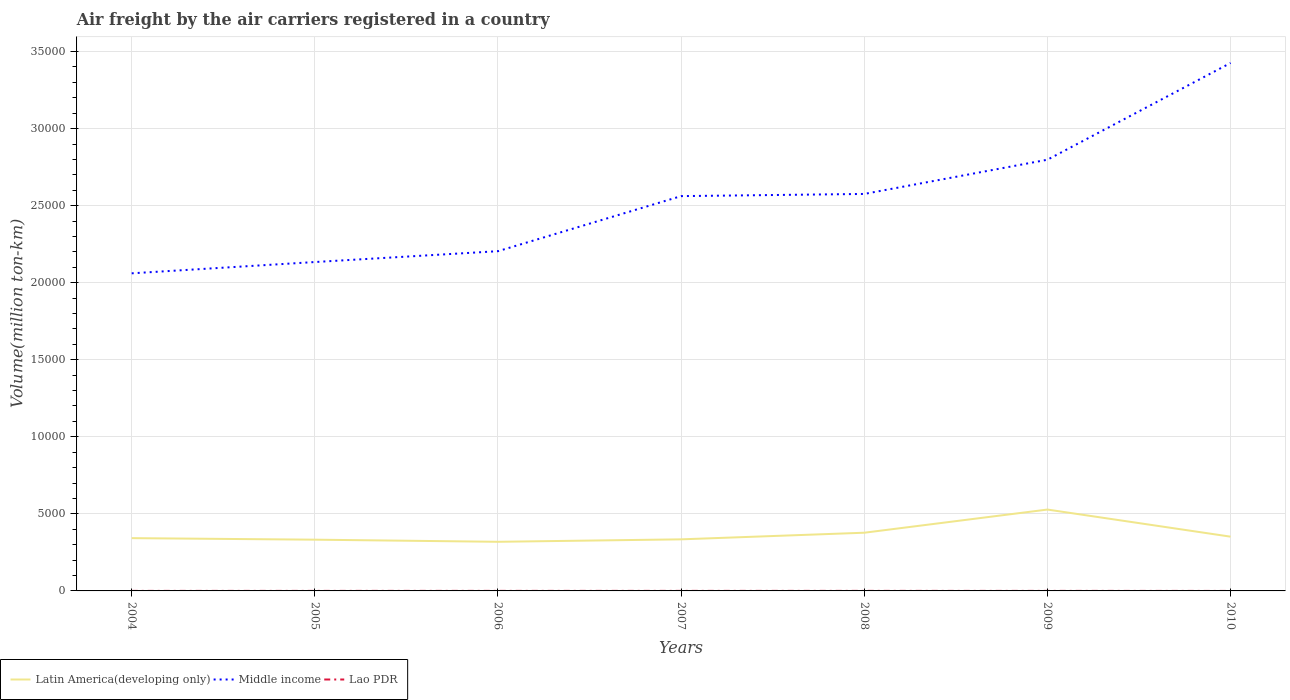How many different coloured lines are there?
Keep it short and to the point. 3. Does the line corresponding to Middle income intersect with the line corresponding to Lao PDR?
Your answer should be compact. No. Across all years, what is the maximum volume of the air carriers in Latin America(developing only)?
Offer a very short reply. 3187.2. In which year was the volume of the air carriers in Lao PDR maximum?
Your answer should be compact. 2010. What is the total volume of the air carriers in Lao PDR in the graph?
Your answer should be compact. 0.18. What is the difference between the highest and the second highest volume of the air carriers in Lao PDR?
Make the answer very short. 2.5. How many lines are there?
Ensure brevity in your answer.  3. How many years are there in the graph?
Your answer should be very brief. 7. Does the graph contain any zero values?
Ensure brevity in your answer.  No. What is the title of the graph?
Make the answer very short. Air freight by the air carriers registered in a country. Does "French Polynesia" appear as one of the legend labels in the graph?
Provide a succinct answer. No. What is the label or title of the Y-axis?
Provide a short and direct response. Volume(million ton-km). What is the Volume(million ton-km) in Latin America(developing only) in 2004?
Your response must be concise. 3425.03. What is the Volume(million ton-km) in Middle income in 2004?
Keep it short and to the point. 2.06e+04. What is the Volume(million ton-km) in Lao PDR in 2004?
Provide a short and direct response. 2.26. What is the Volume(million ton-km) of Latin America(developing only) in 2005?
Provide a short and direct response. 3325.18. What is the Volume(million ton-km) in Middle income in 2005?
Keep it short and to the point. 2.13e+04. What is the Volume(million ton-km) of Lao PDR in 2005?
Offer a terse response. 2.48. What is the Volume(million ton-km) of Latin America(developing only) in 2006?
Ensure brevity in your answer.  3187.2. What is the Volume(million ton-km) in Middle income in 2006?
Provide a short and direct response. 2.20e+04. What is the Volume(million ton-km) of Lao PDR in 2006?
Your answer should be very brief. 2.54. What is the Volume(million ton-km) of Latin America(developing only) in 2007?
Provide a succinct answer. 3347.02. What is the Volume(million ton-km) of Middle income in 2007?
Ensure brevity in your answer.  2.56e+04. What is the Volume(million ton-km) of Lao PDR in 2007?
Your answer should be compact. 2.62. What is the Volume(million ton-km) in Latin America(developing only) in 2008?
Provide a succinct answer. 3776.21. What is the Volume(million ton-km) in Middle income in 2008?
Provide a succinct answer. 2.58e+04. What is the Volume(million ton-km) of Lao PDR in 2008?
Ensure brevity in your answer.  2.58. What is the Volume(million ton-km) of Latin America(developing only) in 2009?
Ensure brevity in your answer.  5279.97. What is the Volume(million ton-km) of Middle income in 2009?
Provide a succinct answer. 2.80e+04. What is the Volume(million ton-km) of Lao PDR in 2009?
Make the answer very short. 2.37. What is the Volume(million ton-km) of Latin America(developing only) in 2010?
Provide a short and direct response. 3520.63. What is the Volume(million ton-km) of Middle income in 2010?
Keep it short and to the point. 3.43e+04. What is the Volume(million ton-km) in Lao PDR in 2010?
Provide a succinct answer. 0.12. Across all years, what is the maximum Volume(million ton-km) in Latin America(developing only)?
Make the answer very short. 5279.97. Across all years, what is the maximum Volume(million ton-km) in Middle income?
Ensure brevity in your answer.  3.43e+04. Across all years, what is the maximum Volume(million ton-km) of Lao PDR?
Offer a terse response. 2.62. Across all years, what is the minimum Volume(million ton-km) in Latin America(developing only)?
Offer a very short reply. 3187.2. Across all years, what is the minimum Volume(million ton-km) in Middle income?
Keep it short and to the point. 2.06e+04. Across all years, what is the minimum Volume(million ton-km) in Lao PDR?
Your answer should be very brief. 0.12. What is the total Volume(million ton-km) in Latin America(developing only) in the graph?
Ensure brevity in your answer.  2.59e+04. What is the total Volume(million ton-km) in Middle income in the graph?
Keep it short and to the point. 1.78e+05. What is the total Volume(million ton-km) of Lao PDR in the graph?
Make the answer very short. 14.98. What is the difference between the Volume(million ton-km) of Latin America(developing only) in 2004 and that in 2005?
Provide a short and direct response. 99.85. What is the difference between the Volume(million ton-km) of Middle income in 2004 and that in 2005?
Provide a succinct answer. -732.44. What is the difference between the Volume(million ton-km) of Lao PDR in 2004 and that in 2005?
Your answer should be very brief. -0.22. What is the difference between the Volume(million ton-km) of Latin America(developing only) in 2004 and that in 2006?
Keep it short and to the point. 237.83. What is the difference between the Volume(million ton-km) of Middle income in 2004 and that in 2006?
Offer a very short reply. -1436.24. What is the difference between the Volume(million ton-km) in Lao PDR in 2004 and that in 2006?
Keep it short and to the point. -0.28. What is the difference between the Volume(million ton-km) in Latin America(developing only) in 2004 and that in 2007?
Make the answer very short. 78.01. What is the difference between the Volume(million ton-km) in Middle income in 2004 and that in 2007?
Provide a succinct answer. -5009.58. What is the difference between the Volume(million ton-km) in Lao PDR in 2004 and that in 2007?
Your answer should be compact. -0.36. What is the difference between the Volume(million ton-km) in Latin America(developing only) in 2004 and that in 2008?
Give a very brief answer. -351.19. What is the difference between the Volume(million ton-km) in Middle income in 2004 and that in 2008?
Provide a succinct answer. -5150.93. What is the difference between the Volume(million ton-km) of Lao PDR in 2004 and that in 2008?
Make the answer very short. -0.32. What is the difference between the Volume(million ton-km) of Latin America(developing only) in 2004 and that in 2009?
Your response must be concise. -1854.94. What is the difference between the Volume(million ton-km) of Middle income in 2004 and that in 2009?
Offer a terse response. -7371.09. What is the difference between the Volume(million ton-km) in Lao PDR in 2004 and that in 2009?
Your answer should be compact. -0.11. What is the difference between the Volume(million ton-km) of Latin America(developing only) in 2004 and that in 2010?
Offer a terse response. -95.61. What is the difference between the Volume(million ton-km) in Middle income in 2004 and that in 2010?
Give a very brief answer. -1.36e+04. What is the difference between the Volume(million ton-km) in Lao PDR in 2004 and that in 2010?
Provide a short and direct response. 2.14. What is the difference between the Volume(million ton-km) in Latin America(developing only) in 2005 and that in 2006?
Your answer should be compact. 137.98. What is the difference between the Volume(million ton-km) in Middle income in 2005 and that in 2006?
Your answer should be very brief. -703.79. What is the difference between the Volume(million ton-km) in Lao PDR in 2005 and that in 2006?
Your response must be concise. -0.06. What is the difference between the Volume(million ton-km) in Latin America(developing only) in 2005 and that in 2007?
Your answer should be compact. -21.84. What is the difference between the Volume(million ton-km) in Middle income in 2005 and that in 2007?
Ensure brevity in your answer.  -4277.14. What is the difference between the Volume(million ton-km) in Lao PDR in 2005 and that in 2007?
Your answer should be compact. -0.14. What is the difference between the Volume(million ton-km) of Latin America(developing only) in 2005 and that in 2008?
Your answer should be compact. -451.04. What is the difference between the Volume(million ton-km) of Middle income in 2005 and that in 2008?
Ensure brevity in your answer.  -4418.49. What is the difference between the Volume(million ton-km) in Lao PDR in 2005 and that in 2008?
Your response must be concise. -0.1. What is the difference between the Volume(million ton-km) of Latin America(developing only) in 2005 and that in 2009?
Your answer should be very brief. -1954.8. What is the difference between the Volume(million ton-km) of Middle income in 2005 and that in 2009?
Offer a very short reply. -6638.65. What is the difference between the Volume(million ton-km) of Lao PDR in 2005 and that in 2009?
Provide a succinct answer. 0.11. What is the difference between the Volume(million ton-km) of Latin America(developing only) in 2005 and that in 2010?
Keep it short and to the point. -195.46. What is the difference between the Volume(million ton-km) of Middle income in 2005 and that in 2010?
Provide a short and direct response. -1.29e+04. What is the difference between the Volume(million ton-km) in Lao PDR in 2005 and that in 2010?
Provide a short and direct response. 2.36. What is the difference between the Volume(million ton-km) in Latin America(developing only) in 2006 and that in 2007?
Offer a very short reply. -159.82. What is the difference between the Volume(million ton-km) in Middle income in 2006 and that in 2007?
Ensure brevity in your answer.  -3573.34. What is the difference between the Volume(million ton-km) of Lao PDR in 2006 and that in 2007?
Provide a short and direct response. -0.08. What is the difference between the Volume(million ton-km) in Latin America(developing only) in 2006 and that in 2008?
Offer a terse response. -589.02. What is the difference between the Volume(million ton-km) of Middle income in 2006 and that in 2008?
Provide a succinct answer. -3714.7. What is the difference between the Volume(million ton-km) of Lao PDR in 2006 and that in 2008?
Your answer should be compact. -0.03. What is the difference between the Volume(million ton-km) in Latin America(developing only) in 2006 and that in 2009?
Your answer should be compact. -2092.77. What is the difference between the Volume(million ton-km) of Middle income in 2006 and that in 2009?
Ensure brevity in your answer.  -5934.85. What is the difference between the Volume(million ton-km) of Lao PDR in 2006 and that in 2009?
Your answer should be compact. 0.18. What is the difference between the Volume(million ton-km) in Latin America(developing only) in 2006 and that in 2010?
Your response must be concise. -333.44. What is the difference between the Volume(million ton-km) in Middle income in 2006 and that in 2010?
Make the answer very short. -1.22e+04. What is the difference between the Volume(million ton-km) in Lao PDR in 2006 and that in 2010?
Ensure brevity in your answer.  2.42. What is the difference between the Volume(million ton-km) of Latin America(developing only) in 2007 and that in 2008?
Offer a very short reply. -429.2. What is the difference between the Volume(million ton-km) in Middle income in 2007 and that in 2008?
Your answer should be compact. -141.35. What is the difference between the Volume(million ton-km) of Lao PDR in 2007 and that in 2008?
Give a very brief answer. 0.05. What is the difference between the Volume(million ton-km) in Latin America(developing only) in 2007 and that in 2009?
Your answer should be compact. -1932.95. What is the difference between the Volume(million ton-km) of Middle income in 2007 and that in 2009?
Your answer should be very brief. -2361.51. What is the difference between the Volume(million ton-km) of Lao PDR in 2007 and that in 2009?
Your answer should be very brief. 0.26. What is the difference between the Volume(million ton-km) in Latin America(developing only) in 2007 and that in 2010?
Your answer should be very brief. -173.62. What is the difference between the Volume(million ton-km) in Middle income in 2007 and that in 2010?
Offer a very short reply. -8639.5. What is the difference between the Volume(million ton-km) in Lao PDR in 2007 and that in 2010?
Offer a very short reply. 2.5. What is the difference between the Volume(million ton-km) in Latin America(developing only) in 2008 and that in 2009?
Your response must be concise. -1503.76. What is the difference between the Volume(million ton-km) of Middle income in 2008 and that in 2009?
Provide a succinct answer. -2220.16. What is the difference between the Volume(million ton-km) in Lao PDR in 2008 and that in 2009?
Your answer should be compact. 0.21. What is the difference between the Volume(million ton-km) of Latin America(developing only) in 2008 and that in 2010?
Offer a terse response. 255.58. What is the difference between the Volume(million ton-km) of Middle income in 2008 and that in 2010?
Provide a short and direct response. -8498.15. What is the difference between the Volume(million ton-km) in Lao PDR in 2008 and that in 2010?
Give a very brief answer. 2.46. What is the difference between the Volume(million ton-km) in Latin America(developing only) in 2009 and that in 2010?
Provide a short and direct response. 1759.34. What is the difference between the Volume(million ton-km) in Middle income in 2009 and that in 2010?
Your answer should be very brief. -6278. What is the difference between the Volume(million ton-km) of Lao PDR in 2009 and that in 2010?
Give a very brief answer. 2.25. What is the difference between the Volume(million ton-km) in Latin America(developing only) in 2004 and the Volume(million ton-km) in Middle income in 2005?
Make the answer very short. -1.79e+04. What is the difference between the Volume(million ton-km) in Latin America(developing only) in 2004 and the Volume(million ton-km) in Lao PDR in 2005?
Offer a terse response. 3422.55. What is the difference between the Volume(million ton-km) of Middle income in 2004 and the Volume(million ton-km) of Lao PDR in 2005?
Keep it short and to the point. 2.06e+04. What is the difference between the Volume(million ton-km) in Latin America(developing only) in 2004 and the Volume(million ton-km) in Middle income in 2006?
Give a very brief answer. -1.86e+04. What is the difference between the Volume(million ton-km) of Latin America(developing only) in 2004 and the Volume(million ton-km) of Lao PDR in 2006?
Make the answer very short. 3422.48. What is the difference between the Volume(million ton-km) in Middle income in 2004 and the Volume(million ton-km) in Lao PDR in 2006?
Your answer should be compact. 2.06e+04. What is the difference between the Volume(million ton-km) of Latin America(developing only) in 2004 and the Volume(million ton-km) of Middle income in 2007?
Your answer should be very brief. -2.22e+04. What is the difference between the Volume(million ton-km) of Latin America(developing only) in 2004 and the Volume(million ton-km) of Lao PDR in 2007?
Offer a very short reply. 3422.4. What is the difference between the Volume(million ton-km) in Middle income in 2004 and the Volume(million ton-km) in Lao PDR in 2007?
Provide a short and direct response. 2.06e+04. What is the difference between the Volume(million ton-km) in Latin America(developing only) in 2004 and the Volume(million ton-km) in Middle income in 2008?
Make the answer very short. -2.23e+04. What is the difference between the Volume(million ton-km) in Latin America(developing only) in 2004 and the Volume(million ton-km) in Lao PDR in 2008?
Ensure brevity in your answer.  3422.45. What is the difference between the Volume(million ton-km) in Middle income in 2004 and the Volume(million ton-km) in Lao PDR in 2008?
Your response must be concise. 2.06e+04. What is the difference between the Volume(million ton-km) of Latin America(developing only) in 2004 and the Volume(million ton-km) of Middle income in 2009?
Offer a terse response. -2.46e+04. What is the difference between the Volume(million ton-km) in Latin America(developing only) in 2004 and the Volume(million ton-km) in Lao PDR in 2009?
Your response must be concise. 3422.66. What is the difference between the Volume(million ton-km) in Middle income in 2004 and the Volume(million ton-km) in Lao PDR in 2009?
Provide a short and direct response. 2.06e+04. What is the difference between the Volume(million ton-km) of Latin America(developing only) in 2004 and the Volume(million ton-km) of Middle income in 2010?
Keep it short and to the point. -3.08e+04. What is the difference between the Volume(million ton-km) of Latin America(developing only) in 2004 and the Volume(million ton-km) of Lao PDR in 2010?
Your answer should be very brief. 3424.9. What is the difference between the Volume(million ton-km) in Middle income in 2004 and the Volume(million ton-km) in Lao PDR in 2010?
Offer a terse response. 2.06e+04. What is the difference between the Volume(million ton-km) of Latin America(developing only) in 2005 and the Volume(million ton-km) of Middle income in 2006?
Offer a terse response. -1.87e+04. What is the difference between the Volume(million ton-km) of Latin America(developing only) in 2005 and the Volume(million ton-km) of Lao PDR in 2006?
Your response must be concise. 3322.63. What is the difference between the Volume(million ton-km) in Middle income in 2005 and the Volume(million ton-km) in Lao PDR in 2006?
Provide a short and direct response. 2.13e+04. What is the difference between the Volume(million ton-km) of Latin America(developing only) in 2005 and the Volume(million ton-km) of Middle income in 2007?
Ensure brevity in your answer.  -2.23e+04. What is the difference between the Volume(million ton-km) of Latin America(developing only) in 2005 and the Volume(million ton-km) of Lao PDR in 2007?
Make the answer very short. 3322.55. What is the difference between the Volume(million ton-km) in Middle income in 2005 and the Volume(million ton-km) in Lao PDR in 2007?
Your answer should be very brief. 2.13e+04. What is the difference between the Volume(million ton-km) in Latin America(developing only) in 2005 and the Volume(million ton-km) in Middle income in 2008?
Keep it short and to the point. -2.24e+04. What is the difference between the Volume(million ton-km) of Latin America(developing only) in 2005 and the Volume(million ton-km) of Lao PDR in 2008?
Make the answer very short. 3322.6. What is the difference between the Volume(million ton-km) of Middle income in 2005 and the Volume(million ton-km) of Lao PDR in 2008?
Your answer should be compact. 2.13e+04. What is the difference between the Volume(million ton-km) in Latin America(developing only) in 2005 and the Volume(million ton-km) in Middle income in 2009?
Your answer should be compact. -2.47e+04. What is the difference between the Volume(million ton-km) in Latin America(developing only) in 2005 and the Volume(million ton-km) in Lao PDR in 2009?
Keep it short and to the point. 3322.81. What is the difference between the Volume(million ton-km) in Middle income in 2005 and the Volume(million ton-km) in Lao PDR in 2009?
Make the answer very short. 2.13e+04. What is the difference between the Volume(million ton-km) of Latin America(developing only) in 2005 and the Volume(million ton-km) of Middle income in 2010?
Provide a succinct answer. -3.09e+04. What is the difference between the Volume(million ton-km) in Latin America(developing only) in 2005 and the Volume(million ton-km) in Lao PDR in 2010?
Your answer should be compact. 3325.05. What is the difference between the Volume(million ton-km) of Middle income in 2005 and the Volume(million ton-km) of Lao PDR in 2010?
Your answer should be compact. 2.13e+04. What is the difference between the Volume(million ton-km) in Latin America(developing only) in 2006 and the Volume(million ton-km) in Middle income in 2007?
Provide a succinct answer. -2.24e+04. What is the difference between the Volume(million ton-km) in Latin America(developing only) in 2006 and the Volume(million ton-km) in Lao PDR in 2007?
Your answer should be compact. 3184.57. What is the difference between the Volume(million ton-km) in Middle income in 2006 and the Volume(million ton-km) in Lao PDR in 2007?
Your answer should be very brief. 2.20e+04. What is the difference between the Volume(million ton-km) of Latin America(developing only) in 2006 and the Volume(million ton-km) of Middle income in 2008?
Give a very brief answer. -2.26e+04. What is the difference between the Volume(million ton-km) of Latin America(developing only) in 2006 and the Volume(million ton-km) of Lao PDR in 2008?
Give a very brief answer. 3184.62. What is the difference between the Volume(million ton-km) in Middle income in 2006 and the Volume(million ton-km) in Lao PDR in 2008?
Give a very brief answer. 2.20e+04. What is the difference between the Volume(million ton-km) of Latin America(developing only) in 2006 and the Volume(million ton-km) of Middle income in 2009?
Your answer should be very brief. -2.48e+04. What is the difference between the Volume(million ton-km) of Latin America(developing only) in 2006 and the Volume(million ton-km) of Lao PDR in 2009?
Your answer should be compact. 3184.83. What is the difference between the Volume(million ton-km) in Middle income in 2006 and the Volume(million ton-km) in Lao PDR in 2009?
Your answer should be compact. 2.20e+04. What is the difference between the Volume(million ton-km) of Latin America(developing only) in 2006 and the Volume(million ton-km) of Middle income in 2010?
Your response must be concise. -3.11e+04. What is the difference between the Volume(million ton-km) of Latin America(developing only) in 2006 and the Volume(million ton-km) of Lao PDR in 2010?
Ensure brevity in your answer.  3187.07. What is the difference between the Volume(million ton-km) of Middle income in 2006 and the Volume(million ton-km) of Lao PDR in 2010?
Your response must be concise. 2.20e+04. What is the difference between the Volume(million ton-km) of Latin America(developing only) in 2007 and the Volume(million ton-km) of Middle income in 2008?
Provide a succinct answer. -2.24e+04. What is the difference between the Volume(million ton-km) in Latin America(developing only) in 2007 and the Volume(million ton-km) in Lao PDR in 2008?
Give a very brief answer. 3344.44. What is the difference between the Volume(million ton-km) in Middle income in 2007 and the Volume(million ton-km) in Lao PDR in 2008?
Your answer should be very brief. 2.56e+04. What is the difference between the Volume(million ton-km) in Latin America(developing only) in 2007 and the Volume(million ton-km) in Middle income in 2009?
Your answer should be compact. -2.46e+04. What is the difference between the Volume(million ton-km) in Latin America(developing only) in 2007 and the Volume(million ton-km) in Lao PDR in 2009?
Ensure brevity in your answer.  3344.65. What is the difference between the Volume(million ton-km) in Middle income in 2007 and the Volume(million ton-km) in Lao PDR in 2009?
Make the answer very short. 2.56e+04. What is the difference between the Volume(million ton-km) of Latin America(developing only) in 2007 and the Volume(million ton-km) of Middle income in 2010?
Keep it short and to the point. -3.09e+04. What is the difference between the Volume(million ton-km) in Latin America(developing only) in 2007 and the Volume(million ton-km) in Lao PDR in 2010?
Offer a very short reply. 3346.89. What is the difference between the Volume(million ton-km) in Middle income in 2007 and the Volume(million ton-km) in Lao PDR in 2010?
Give a very brief answer. 2.56e+04. What is the difference between the Volume(million ton-km) in Latin America(developing only) in 2008 and the Volume(million ton-km) in Middle income in 2009?
Your answer should be compact. -2.42e+04. What is the difference between the Volume(million ton-km) in Latin America(developing only) in 2008 and the Volume(million ton-km) in Lao PDR in 2009?
Your answer should be very brief. 3773.85. What is the difference between the Volume(million ton-km) of Middle income in 2008 and the Volume(million ton-km) of Lao PDR in 2009?
Offer a very short reply. 2.58e+04. What is the difference between the Volume(million ton-km) of Latin America(developing only) in 2008 and the Volume(million ton-km) of Middle income in 2010?
Offer a terse response. -3.05e+04. What is the difference between the Volume(million ton-km) of Latin America(developing only) in 2008 and the Volume(million ton-km) of Lao PDR in 2010?
Make the answer very short. 3776.09. What is the difference between the Volume(million ton-km) in Middle income in 2008 and the Volume(million ton-km) in Lao PDR in 2010?
Ensure brevity in your answer.  2.58e+04. What is the difference between the Volume(million ton-km) in Latin America(developing only) in 2009 and the Volume(million ton-km) in Middle income in 2010?
Your answer should be very brief. -2.90e+04. What is the difference between the Volume(million ton-km) in Latin America(developing only) in 2009 and the Volume(million ton-km) in Lao PDR in 2010?
Your response must be concise. 5279.85. What is the difference between the Volume(million ton-km) of Middle income in 2009 and the Volume(million ton-km) of Lao PDR in 2010?
Provide a succinct answer. 2.80e+04. What is the average Volume(million ton-km) in Latin America(developing only) per year?
Ensure brevity in your answer.  3694.46. What is the average Volume(million ton-km) in Middle income per year?
Keep it short and to the point. 2.54e+04. What is the average Volume(million ton-km) of Lao PDR per year?
Ensure brevity in your answer.  2.14. In the year 2004, what is the difference between the Volume(million ton-km) in Latin America(developing only) and Volume(million ton-km) in Middle income?
Your answer should be compact. -1.72e+04. In the year 2004, what is the difference between the Volume(million ton-km) in Latin America(developing only) and Volume(million ton-km) in Lao PDR?
Provide a short and direct response. 3422.76. In the year 2004, what is the difference between the Volume(million ton-km) of Middle income and Volume(million ton-km) of Lao PDR?
Give a very brief answer. 2.06e+04. In the year 2005, what is the difference between the Volume(million ton-km) of Latin America(developing only) and Volume(million ton-km) of Middle income?
Make the answer very short. -1.80e+04. In the year 2005, what is the difference between the Volume(million ton-km) of Latin America(developing only) and Volume(million ton-km) of Lao PDR?
Give a very brief answer. 3322.7. In the year 2005, what is the difference between the Volume(million ton-km) in Middle income and Volume(million ton-km) in Lao PDR?
Your answer should be very brief. 2.13e+04. In the year 2006, what is the difference between the Volume(million ton-km) of Latin America(developing only) and Volume(million ton-km) of Middle income?
Ensure brevity in your answer.  -1.89e+04. In the year 2006, what is the difference between the Volume(million ton-km) in Latin America(developing only) and Volume(million ton-km) in Lao PDR?
Provide a succinct answer. 3184.65. In the year 2006, what is the difference between the Volume(million ton-km) in Middle income and Volume(million ton-km) in Lao PDR?
Ensure brevity in your answer.  2.20e+04. In the year 2007, what is the difference between the Volume(million ton-km) of Latin America(developing only) and Volume(million ton-km) of Middle income?
Ensure brevity in your answer.  -2.23e+04. In the year 2007, what is the difference between the Volume(million ton-km) in Latin America(developing only) and Volume(million ton-km) in Lao PDR?
Offer a terse response. 3344.39. In the year 2007, what is the difference between the Volume(million ton-km) of Middle income and Volume(million ton-km) of Lao PDR?
Offer a terse response. 2.56e+04. In the year 2008, what is the difference between the Volume(million ton-km) of Latin America(developing only) and Volume(million ton-km) of Middle income?
Your response must be concise. -2.20e+04. In the year 2008, what is the difference between the Volume(million ton-km) in Latin America(developing only) and Volume(million ton-km) in Lao PDR?
Offer a terse response. 3773.64. In the year 2008, what is the difference between the Volume(million ton-km) in Middle income and Volume(million ton-km) in Lao PDR?
Give a very brief answer. 2.58e+04. In the year 2009, what is the difference between the Volume(million ton-km) of Latin America(developing only) and Volume(million ton-km) of Middle income?
Make the answer very short. -2.27e+04. In the year 2009, what is the difference between the Volume(million ton-km) in Latin America(developing only) and Volume(million ton-km) in Lao PDR?
Your answer should be compact. 5277.6. In the year 2009, what is the difference between the Volume(million ton-km) of Middle income and Volume(million ton-km) of Lao PDR?
Offer a very short reply. 2.80e+04. In the year 2010, what is the difference between the Volume(million ton-km) of Latin America(developing only) and Volume(million ton-km) of Middle income?
Your answer should be very brief. -3.07e+04. In the year 2010, what is the difference between the Volume(million ton-km) in Latin America(developing only) and Volume(million ton-km) in Lao PDR?
Offer a very short reply. 3520.51. In the year 2010, what is the difference between the Volume(million ton-km) of Middle income and Volume(million ton-km) of Lao PDR?
Provide a short and direct response. 3.43e+04. What is the ratio of the Volume(million ton-km) in Middle income in 2004 to that in 2005?
Offer a terse response. 0.97. What is the ratio of the Volume(million ton-km) of Lao PDR in 2004 to that in 2005?
Provide a succinct answer. 0.91. What is the ratio of the Volume(million ton-km) in Latin America(developing only) in 2004 to that in 2006?
Your response must be concise. 1.07. What is the ratio of the Volume(million ton-km) in Middle income in 2004 to that in 2006?
Your answer should be compact. 0.93. What is the ratio of the Volume(million ton-km) of Lao PDR in 2004 to that in 2006?
Your response must be concise. 0.89. What is the ratio of the Volume(million ton-km) in Latin America(developing only) in 2004 to that in 2007?
Keep it short and to the point. 1.02. What is the ratio of the Volume(million ton-km) in Middle income in 2004 to that in 2007?
Provide a succinct answer. 0.8. What is the ratio of the Volume(million ton-km) of Lao PDR in 2004 to that in 2007?
Provide a short and direct response. 0.86. What is the ratio of the Volume(million ton-km) in Latin America(developing only) in 2004 to that in 2008?
Give a very brief answer. 0.91. What is the ratio of the Volume(million ton-km) in Middle income in 2004 to that in 2008?
Offer a terse response. 0.8. What is the ratio of the Volume(million ton-km) in Lao PDR in 2004 to that in 2008?
Provide a succinct answer. 0.88. What is the ratio of the Volume(million ton-km) in Latin America(developing only) in 2004 to that in 2009?
Keep it short and to the point. 0.65. What is the ratio of the Volume(million ton-km) of Middle income in 2004 to that in 2009?
Your response must be concise. 0.74. What is the ratio of the Volume(million ton-km) of Lao PDR in 2004 to that in 2009?
Provide a short and direct response. 0.96. What is the ratio of the Volume(million ton-km) of Latin America(developing only) in 2004 to that in 2010?
Give a very brief answer. 0.97. What is the ratio of the Volume(million ton-km) in Middle income in 2004 to that in 2010?
Your answer should be very brief. 0.6. What is the ratio of the Volume(million ton-km) in Lao PDR in 2004 to that in 2010?
Make the answer very short. 18.53. What is the ratio of the Volume(million ton-km) in Latin America(developing only) in 2005 to that in 2006?
Give a very brief answer. 1.04. What is the ratio of the Volume(million ton-km) in Middle income in 2005 to that in 2006?
Provide a succinct answer. 0.97. What is the ratio of the Volume(million ton-km) of Lao PDR in 2005 to that in 2006?
Provide a short and direct response. 0.97. What is the ratio of the Volume(million ton-km) of Latin America(developing only) in 2005 to that in 2007?
Your answer should be compact. 0.99. What is the ratio of the Volume(million ton-km) of Middle income in 2005 to that in 2007?
Offer a very short reply. 0.83. What is the ratio of the Volume(million ton-km) in Lao PDR in 2005 to that in 2007?
Give a very brief answer. 0.95. What is the ratio of the Volume(million ton-km) of Latin America(developing only) in 2005 to that in 2008?
Your answer should be compact. 0.88. What is the ratio of the Volume(million ton-km) of Middle income in 2005 to that in 2008?
Provide a succinct answer. 0.83. What is the ratio of the Volume(million ton-km) in Latin America(developing only) in 2005 to that in 2009?
Make the answer very short. 0.63. What is the ratio of the Volume(million ton-km) of Middle income in 2005 to that in 2009?
Your response must be concise. 0.76. What is the ratio of the Volume(million ton-km) of Lao PDR in 2005 to that in 2009?
Provide a succinct answer. 1.05. What is the ratio of the Volume(million ton-km) of Latin America(developing only) in 2005 to that in 2010?
Your answer should be compact. 0.94. What is the ratio of the Volume(million ton-km) of Middle income in 2005 to that in 2010?
Offer a terse response. 0.62. What is the ratio of the Volume(million ton-km) in Lao PDR in 2005 to that in 2010?
Provide a succinct answer. 20.34. What is the ratio of the Volume(million ton-km) in Latin America(developing only) in 2006 to that in 2007?
Keep it short and to the point. 0.95. What is the ratio of the Volume(million ton-km) of Middle income in 2006 to that in 2007?
Give a very brief answer. 0.86. What is the ratio of the Volume(million ton-km) of Lao PDR in 2006 to that in 2007?
Your response must be concise. 0.97. What is the ratio of the Volume(million ton-km) in Latin America(developing only) in 2006 to that in 2008?
Your answer should be compact. 0.84. What is the ratio of the Volume(million ton-km) of Middle income in 2006 to that in 2008?
Your answer should be compact. 0.86. What is the ratio of the Volume(million ton-km) of Latin America(developing only) in 2006 to that in 2009?
Provide a succinct answer. 0.6. What is the ratio of the Volume(million ton-km) of Middle income in 2006 to that in 2009?
Offer a very short reply. 0.79. What is the ratio of the Volume(million ton-km) in Lao PDR in 2006 to that in 2009?
Make the answer very short. 1.08. What is the ratio of the Volume(million ton-km) in Latin America(developing only) in 2006 to that in 2010?
Your answer should be compact. 0.91. What is the ratio of the Volume(million ton-km) in Middle income in 2006 to that in 2010?
Make the answer very short. 0.64. What is the ratio of the Volume(million ton-km) of Lao PDR in 2006 to that in 2010?
Keep it short and to the point. 20.86. What is the ratio of the Volume(million ton-km) of Latin America(developing only) in 2007 to that in 2008?
Offer a very short reply. 0.89. What is the ratio of the Volume(million ton-km) of Middle income in 2007 to that in 2008?
Your answer should be compact. 0.99. What is the ratio of the Volume(million ton-km) of Lao PDR in 2007 to that in 2008?
Give a very brief answer. 1.02. What is the ratio of the Volume(million ton-km) in Latin America(developing only) in 2007 to that in 2009?
Make the answer very short. 0.63. What is the ratio of the Volume(million ton-km) in Middle income in 2007 to that in 2009?
Give a very brief answer. 0.92. What is the ratio of the Volume(million ton-km) of Lao PDR in 2007 to that in 2009?
Your answer should be very brief. 1.11. What is the ratio of the Volume(million ton-km) in Latin America(developing only) in 2007 to that in 2010?
Make the answer very short. 0.95. What is the ratio of the Volume(million ton-km) in Middle income in 2007 to that in 2010?
Make the answer very short. 0.75. What is the ratio of the Volume(million ton-km) of Lao PDR in 2007 to that in 2010?
Your answer should be compact. 21.52. What is the ratio of the Volume(million ton-km) of Latin America(developing only) in 2008 to that in 2009?
Offer a terse response. 0.72. What is the ratio of the Volume(million ton-km) in Middle income in 2008 to that in 2009?
Your answer should be very brief. 0.92. What is the ratio of the Volume(million ton-km) in Lao PDR in 2008 to that in 2009?
Give a very brief answer. 1.09. What is the ratio of the Volume(million ton-km) of Latin America(developing only) in 2008 to that in 2010?
Your response must be concise. 1.07. What is the ratio of the Volume(million ton-km) in Middle income in 2008 to that in 2010?
Offer a very short reply. 0.75. What is the ratio of the Volume(million ton-km) in Lao PDR in 2008 to that in 2010?
Your response must be concise. 21.14. What is the ratio of the Volume(million ton-km) of Latin America(developing only) in 2009 to that in 2010?
Provide a succinct answer. 1.5. What is the ratio of the Volume(million ton-km) of Middle income in 2009 to that in 2010?
Your answer should be very brief. 0.82. What is the ratio of the Volume(million ton-km) of Lao PDR in 2009 to that in 2010?
Offer a terse response. 19.4. What is the difference between the highest and the second highest Volume(million ton-km) of Latin America(developing only)?
Provide a succinct answer. 1503.76. What is the difference between the highest and the second highest Volume(million ton-km) of Middle income?
Offer a terse response. 6278. What is the difference between the highest and the second highest Volume(million ton-km) in Lao PDR?
Make the answer very short. 0.05. What is the difference between the highest and the lowest Volume(million ton-km) of Latin America(developing only)?
Your answer should be very brief. 2092.77. What is the difference between the highest and the lowest Volume(million ton-km) in Middle income?
Provide a succinct answer. 1.36e+04. What is the difference between the highest and the lowest Volume(million ton-km) of Lao PDR?
Offer a very short reply. 2.5. 